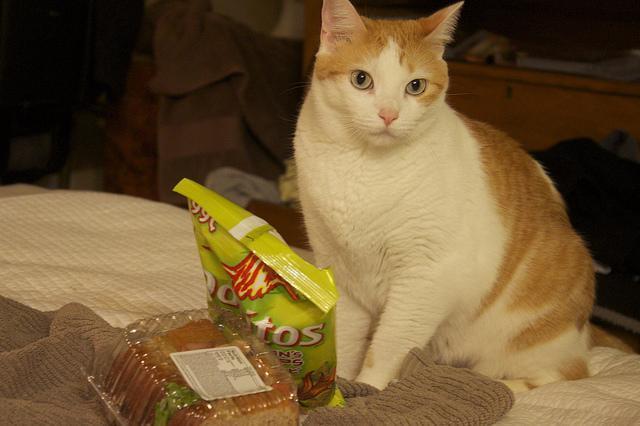How many animals are in this photo?
Give a very brief answer. 1. How many cats can you see?
Give a very brief answer. 1. How many people are shown?
Give a very brief answer. 0. 